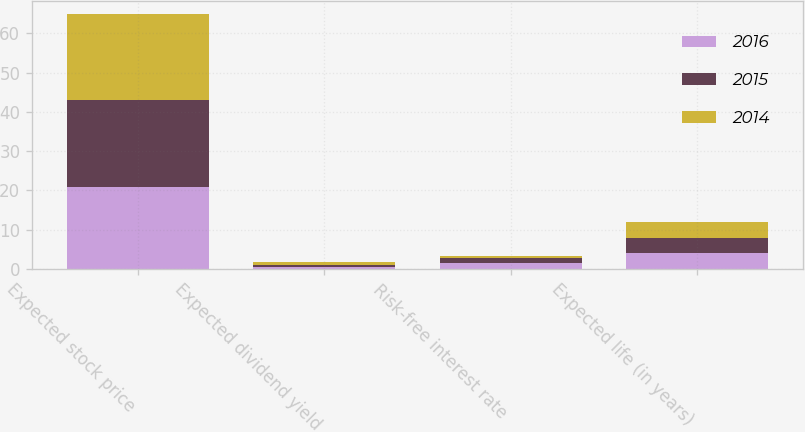Convert chart. <chart><loc_0><loc_0><loc_500><loc_500><stacked_bar_chart><ecel><fcel>Expected stock price<fcel>Expected dividend yield<fcel>Risk-free interest rate<fcel>Expected life (in years)<nl><fcel>2016<fcel>21<fcel>0.4<fcel>1.4<fcel>4<nl><fcel>2015<fcel>22<fcel>0.6<fcel>1.3<fcel>4<nl><fcel>2014<fcel>22<fcel>0.7<fcel>0.7<fcel>4<nl></chart> 